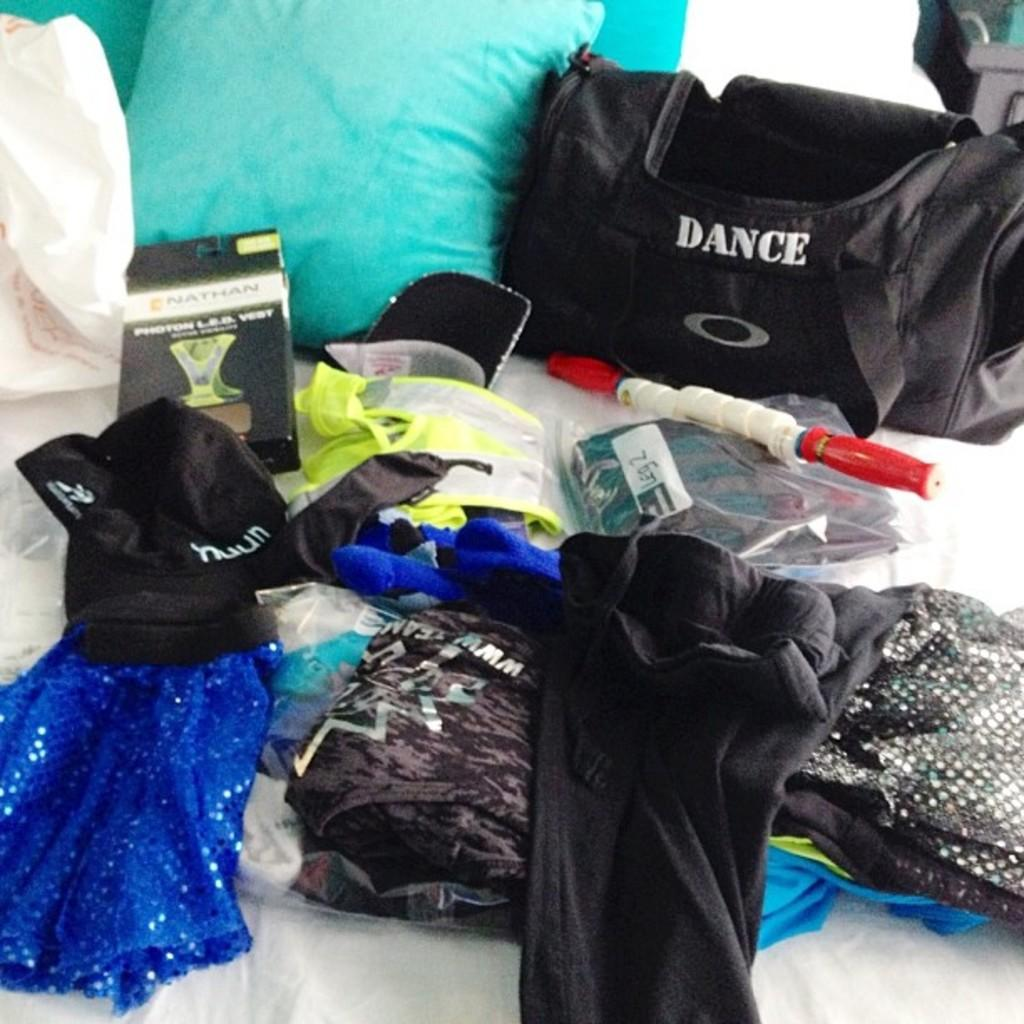What type of items can be seen in the image? There are clothes, a box cab, a bag, pillows, and a carry bag in the image. Where are these items located? All of these items are on a bed in the image. What might be used for carrying or holding items in the image? There is a bag and a carry bag in the image that can be used for carrying or holding items. What might be used for comfort or relaxation in the image? The pillows in the image might be used for comfort or relaxation. What book is being read by the sisters in the image? There are no sisters or books present in the image. What type of pollution can be seen in the image? There is no pollution present in the image. 